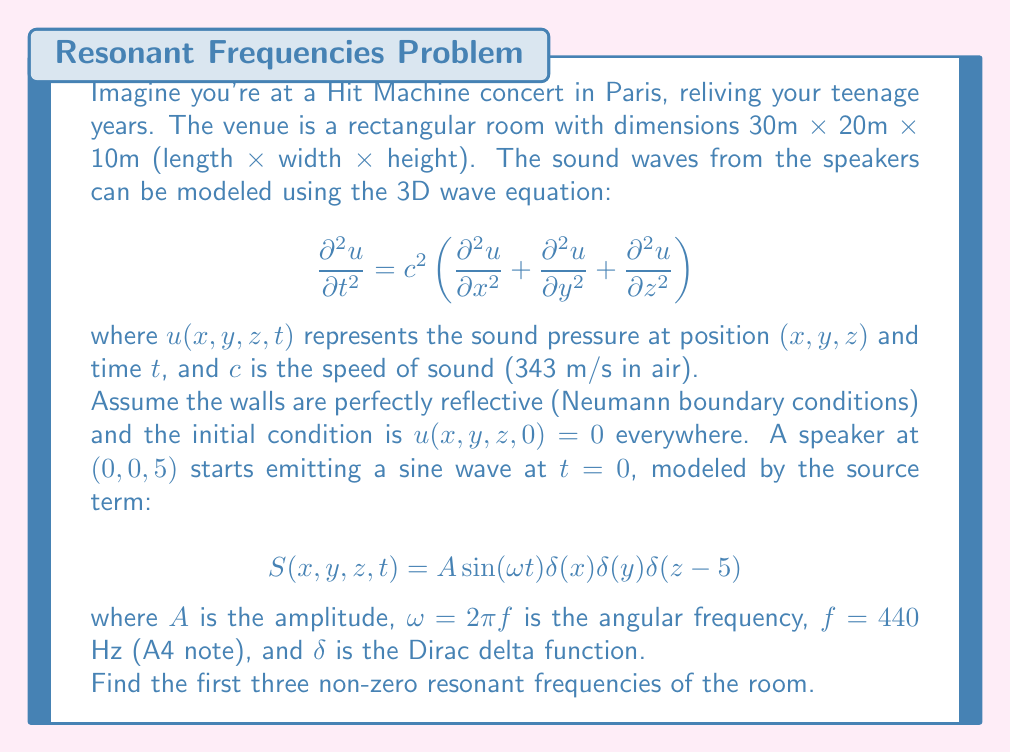Could you help me with this problem? To solve this problem, we need to follow these steps:

1) First, we recognize that the resonant frequencies of the room are independent of the source term and only depend on the room's dimensions and boundary conditions.

2) For a rectangular room with perfectly reflective walls (Neumann boundary conditions), the resonant frequencies are given by the formula:

   $$f_{l,m,n} = \frac{c}{2}\sqrt{\left(\frac{l}{L_x}\right)^2 + \left(\frac{m}{L_y}\right)^2 + \left(\frac{n}{L_z}\right)^2}$$

   where $L_x$, $L_y$, and $L_z$ are the room dimensions, and $l$, $m$, and $n$ are non-negative integers, not all zero.

3) Let's substitute the given values:
   $c = 343$ m/s
   $L_x = 30$ m
   $L_y = 20$ m
   $L_z = 10$ m

4) Now we need to calculate the frequencies for different combinations of $l$, $m$, and $n$:

   For $(l,m,n) = (1,0,0)$: $f_{1,0,0} = \frac{343}{2}\sqrt{\left(\frac{1}{30}\right)^2} = 5.72$ Hz

   For $(l,m,n) = (0,1,0)$: $f_{0,1,0} = \frac{343}{2}\sqrt{\left(\frac{1}{20}\right)^2} = 8.58$ Hz

   For $(l,m,n) = (0,0,1)$: $f_{0,0,1} = \frac{343}{2}\sqrt{\left(\frac{1}{10}\right)^2} = 17.15$ Hz

   For $(l,m,n) = (1,1,0)$: $f_{1,1,0} = \frac{343}{2}\sqrt{\left(\frac{1}{30}\right)^2 + \left(\frac{1}{20}\right)^2} = 10.30$ Hz

5) Ordering these frequencies from lowest to highest, we get:
   5.72 Hz, 8.58 Hz, 10.30 Hz, 17.15 Hz, ...

6) The first three non-zero resonant frequencies are therefore 5.72 Hz, 8.58 Hz, and 10.30 Hz.
Answer: The first three non-zero resonant frequencies of the room are:
1) 5.72 Hz
2) 8.58 Hz
3) 10.30 Hz 